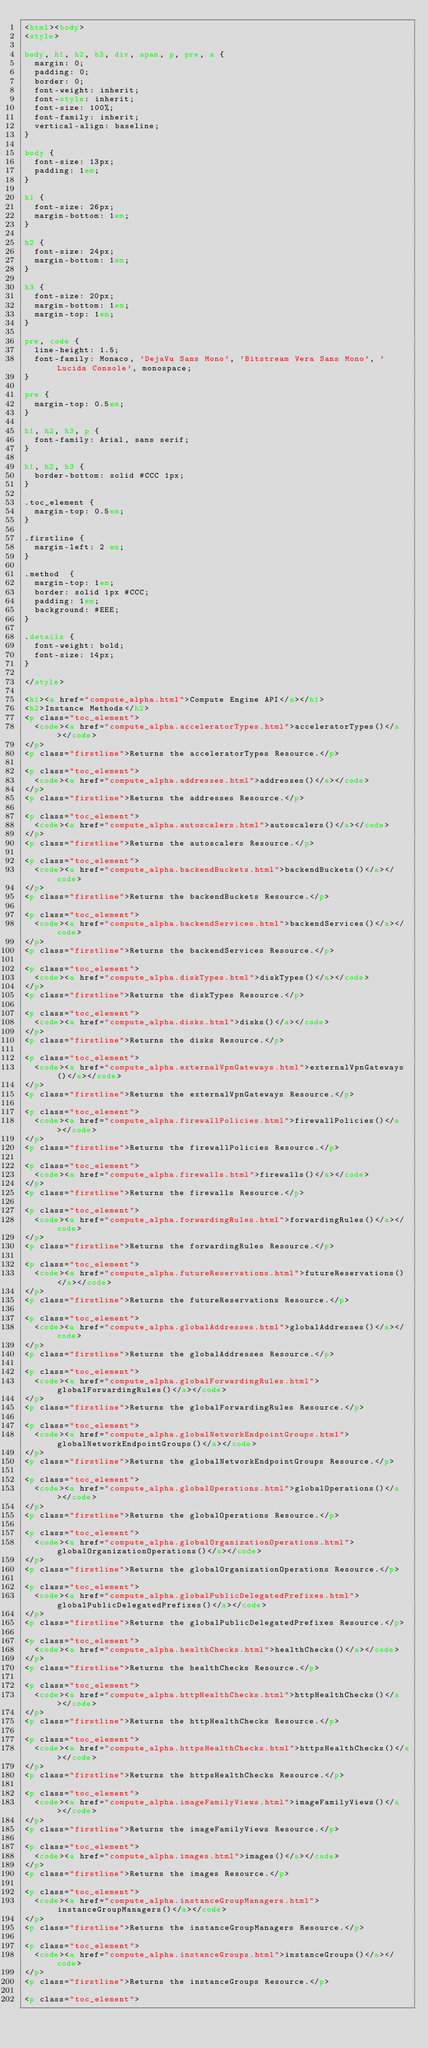<code> <loc_0><loc_0><loc_500><loc_500><_HTML_><html><body>
<style>

body, h1, h2, h3, div, span, p, pre, a {
  margin: 0;
  padding: 0;
  border: 0;
  font-weight: inherit;
  font-style: inherit;
  font-size: 100%;
  font-family: inherit;
  vertical-align: baseline;
}

body {
  font-size: 13px;
  padding: 1em;
}

h1 {
  font-size: 26px;
  margin-bottom: 1em;
}

h2 {
  font-size: 24px;
  margin-bottom: 1em;
}

h3 {
  font-size: 20px;
  margin-bottom: 1em;
  margin-top: 1em;
}

pre, code {
  line-height: 1.5;
  font-family: Monaco, 'DejaVu Sans Mono', 'Bitstream Vera Sans Mono', 'Lucida Console', monospace;
}

pre {
  margin-top: 0.5em;
}

h1, h2, h3, p {
  font-family: Arial, sans serif;
}

h1, h2, h3 {
  border-bottom: solid #CCC 1px;
}

.toc_element {
  margin-top: 0.5em;
}

.firstline {
  margin-left: 2 em;
}

.method  {
  margin-top: 1em;
  border: solid 1px #CCC;
  padding: 1em;
  background: #EEE;
}

.details {
  font-weight: bold;
  font-size: 14px;
}

</style>

<h1><a href="compute_alpha.html">Compute Engine API</a></h1>
<h2>Instance Methods</h2>
<p class="toc_element">
  <code><a href="compute_alpha.acceleratorTypes.html">acceleratorTypes()</a></code>
</p>
<p class="firstline">Returns the acceleratorTypes Resource.</p>

<p class="toc_element">
  <code><a href="compute_alpha.addresses.html">addresses()</a></code>
</p>
<p class="firstline">Returns the addresses Resource.</p>

<p class="toc_element">
  <code><a href="compute_alpha.autoscalers.html">autoscalers()</a></code>
</p>
<p class="firstline">Returns the autoscalers Resource.</p>

<p class="toc_element">
  <code><a href="compute_alpha.backendBuckets.html">backendBuckets()</a></code>
</p>
<p class="firstline">Returns the backendBuckets Resource.</p>

<p class="toc_element">
  <code><a href="compute_alpha.backendServices.html">backendServices()</a></code>
</p>
<p class="firstline">Returns the backendServices Resource.</p>

<p class="toc_element">
  <code><a href="compute_alpha.diskTypes.html">diskTypes()</a></code>
</p>
<p class="firstline">Returns the diskTypes Resource.</p>

<p class="toc_element">
  <code><a href="compute_alpha.disks.html">disks()</a></code>
</p>
<p class="firstline">Returns the disks Resource.</p>

<p class="toc_element">
  <code><a href="compute_alpha.externalVpnGateways.html">externalVpnGateways()</a></code>
</p>
<p class="firstline">Returns the externalVpnGateways Resource.</p>

<p class="toc_element">
  <code><a href="compute_alpha.firewallPolicies.html">firewallPolicies()</a></code>
</p>
<p class="firstline">Returns the firewallPolicies Resource.</p>

<p class="toc_element">
  <code><a href="compute_alpha.firewalls.html">firewalls()</a></code>
</p>
<p class="firstline">Returns the firewalls Resource.</p>

<p class="toc_element">
  <code><a href="compute_alpha.forwardingRules.html">forwardingRules()</a></code>
</p>
<p class="firstline">Returns the forwardingRules Resource.</p>

<p class="toc_element">
  <code><a href="compute_alpha.futureReservations.html">futureReservations()</a></code>
</p>
<p class="firstline">Returns the futureReservations Resource.</p>

<p class="toc_element">
  <code><a href="compute_alpha.globalAddresses.html">globalAddresses()</a></code>
</p>
<p class="firstline">Returns the globalAddresses Resource.</p>

<p class="toc_element">
  <code><a href="compute_alpha.globalForwardingRules.html">globalForwardingRules()</a></code>
</p>
<p class="firstline">Returns the globalForwardingRules Resource.</p>

<p class="toc_element">
  <code><a href="compute_alpha.globalNetworkEndpointGroups.html">globalNetworkEndpointGroups()</a></code>
</p>
<p class="firstline">Returns the globalNetworkEndpointGroups Resource.</p>

<p class="toc_element">
  <code><a href="compute_alpha.globalOperations.html">globalOperations()</a></code>
</p>
<p class="firstline">Returns the globalOperations Resource.</p>

<p class="toc_element">
  <code><a href="compute_alpha.globalOrganizationOperations.html">globalOrganizationOperations()</a></code>
</p>
<p class="firstline">Returns the globalOrganizationOperations Resource.</p>

<p class="toc_element">
  <code><a href="compute_alpha.globalPublicDelegatedPrefixes.html">globalPublicDelegatedPrefixes()</a></code>
</p>
<p class="firstline">Returns the globalPublicDelegatedPrefixes Resource.</p>

<p class="toc_element">
  <code><a href="compute_alpha.healthChecks.html">healthChecks()</a></code>
</p>
<p class="firstline">Returns the healthChecks Resource.</p>

<p class="toc_element">
  <code><a href="compute_alpha.httpHealthChecks.html">httpHealthChecks()</a></code>
</p>
<p class="firstline">Returns the httpHealthChecks Resource.</p>

<p class="toc_element">
  <code><a href="compute_alpha.httpsHealthChecks.html">httpsHealthChecks()</a></code>
</p>
<p class="firstline">Returns the httpsHealthChecks Resource.</p>

<p class="toc_element">
  <code><a href="compute_alpha.imageFamilyViews.html">imageFamilyViews()</a></code>
</p>
<p class="firstline">Returns the imageFamilyViews Resource.</p>

<p class="toc_element">
  <code><a href="compute_alpha.images.html">images()</a></code>
</p>
<p class="firstline">Returns the images Resource.</p>

<p class="toc_element">
  <code><a href="compute_alpha.instanceGroupManagers.html">instanceGroupManagers()</a></code>
</p>
<p class="firstline">Returns the instanceGroupManagers Resource.</p>

<p class="toc_element">
  <code><a href="compute_alpha.instanceGroups.html">instanceGroups()</a></code>
</p>
<p class="firstline">Returns the instanceGroups Resource.</p>

<p class="toc_element"></code> 